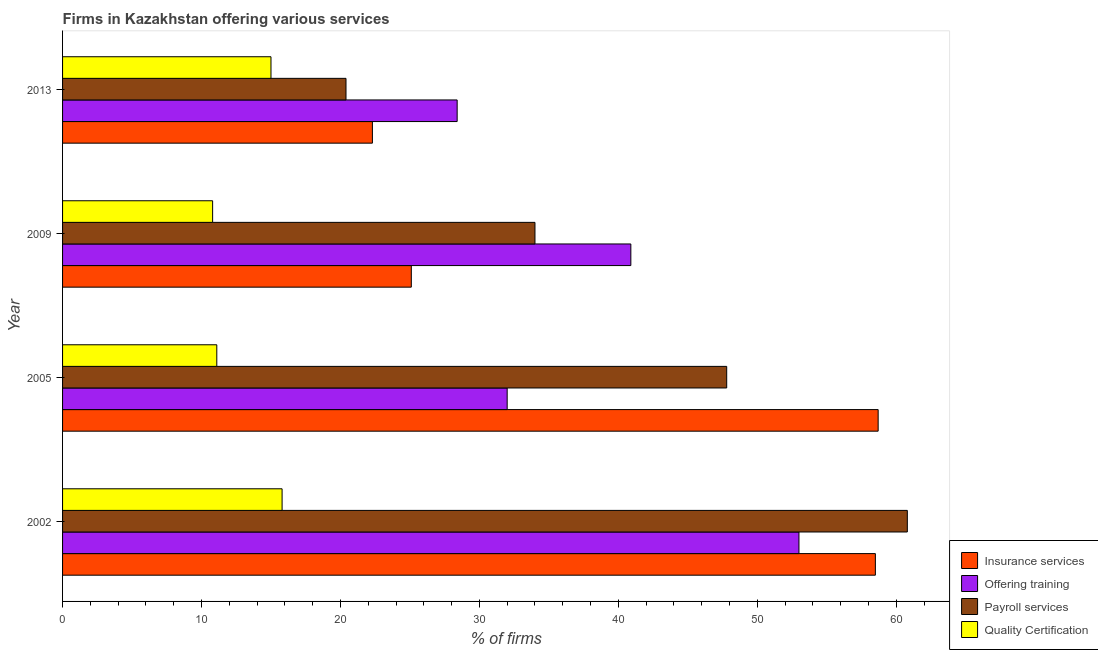How many different coloured bars are there?
Ensure brevity in your answer.  4. Are the number of bars on each tick of the Y-axis equal?
Your response must be concise. Yes. In how many cases, is the number of bars for a given year not equal to the number of legend labels?
Your answer should be compact. 0. What is the percentage of firms offering payroll services in 2002?
Make the answer very short. 60.8. Across all years, what is the maximum percentage of firms offering insurance services?
Ensure brevity in your answer.  58.7. Across all years, what is the minimum percentage of firms offering payroll services?
Your answer should be compact. 20.4. In which year was the percentage of firms offering payroll services maximum?
Offer a very short reply. 2002. What is the total percentage of firms offering quality certification in the graph?
Your answer should be compact. 52.7. What is the difference between the percentage of firms offering training in 2002 and that in 2013?
Offer a terse response. 24.6. What is the average percentage of firms offering quality certification per year?
Provide a succinct answer. 13.18. In the year 2009, what is the difference between the percentage of firms offering quality certification and percentage of firms offering insurance services?
Offer a very short reply. -14.3. In how many years, is the percentage of firms offering training greater than 6 %?
Ensure brevity in your answer.  4. What is the ratio of the percentage of firms offering payroll services in 2005 to that in 2009?
Offer a very short reply. 1.41. Is the difference between the percentage of firms offering insurance services in 2005 and 2009 greater than the difference between the percentage of firms offering payroll services in 2005 and 2009?
Provide a short and direct response. Yes. What is the difference between the highest and the second highest percentage of firms offering insurance services?
Keep it short and to the point. 0.2. What is the difference between the highest and the lowest percentage of firms offering training?
Your answer should be very brief. 24.6. In how many years, is the percentage of firms offering insurance services greater than the average percentage of firms offering insurance services taken over all years?
Your answer should be compact. 2. Is the sum of the percentage of firms offering payroll services in 2002 and 2005 greater than the maximum percentage of firms offering training across all years?
Provide a short and direct response. Yes. Is it the case that in every year, the sum of the percentage of firms offering training and percentage of firms offering payroll services is greater than the sum of percentage of firms offering insurance services and percentage of firms offering quality certification?
Your response must be concise. No. What does the 2nd bar from the top in 2013 represents?
Your answer should be very brief. Payroll services. What does the 1st bar from the bottom in 2005 represents?
Make the answer very short. Insurance services. How many years are there in the graph?
Offer a terse response. 4. Are the values on the major ticks of X-axis written in scientific E-notation?
Offer a very short reply. No. Where does the legend appear in the graph?
Make the answer very short. Bottom right. What is the title of the graph?
Give a very brief answer. Firms in Kazakhstan offering various services . What is the label or title of the X-axis?
Your answer should be very brief. % of firms. What is the label or title of the Y-axis?
Provide a succinct answer. Year. What is the % of firms in Insurance services in 2002?
Provide a succinct answer. 58.5. What is the % of firms in Offering training in 2002?
Offer a terse response. 53. What is the % of firms in Payroll services in 2002?
Provide a short and direct response. 60.8. What is the % of firms in Insurance services in 2005?
Make the answer very short. 58.7. What is the % of firms in Payroll services in 2005?
Make the answer very short. 47.8. What is the % of firms in Quality Certification in 2005?
Give a very brief answer. 11.1. What is the % of firms in Insurance services in 2009?
Your answer should be compact. 25.1. What is the % of firms of Offering training in 2009?
Ensure brevity in your answer.  40.9. What is the % of firms in Insurance services in 2013?
Provide a succinct answer. 22.3. What is the % of firms in Offering training in 2013?
Your answer should be compact. 28.4. What is the % of firms of Payroll services in 2013?
Your answer should be compact. 20.4. What is the % of firms in Quality Certification in 2013?
Give a very brief answer. 15. Across all years, what is the maximum % of firms of Insurance services?
Your answer should be compact. 58.7. Across all years, what is the maximum % of firms of Payroll services?
Provide a succinct answer. 60.8. Across all years, what is the maximum % of firms in Quality Certification?
Offer a terse response. 15.8. Across all years, what is the minimum % of firms of Insurance services?
Keep it short and to the point. 22.3. Across all years, what is the minimum % of firms in Offering training?
Offer a very short reply. 28.4. Across all years, what is the minimum % of firms of Payroll services?
Make the answer very short. 20.4. What is the total % of firms in Insurance services in the graph?
Your answer should be very brief. 164.6. What is the total % of firms of Offering training in the graph?
Your answer should be compact. 154.3. What is the total % of firms in Payroll services in the graph?
Offer a very short reply. 163. What is the total % of firms of Quality Certification in the graph?
Offer a terse response. 52.7. What is the difference between the % of firms of Offering training in 2002 and that in 2005?
Your answer should be very brief. 21. What is the difference between the % of firms in Payroll services in 2002 and that in 2005?
Provide a short and direct response. 13. What is the difference between the % of firms of Quality Certification in 2002 and that in 2005?
Offer a terse response. 4.7. What is the difference between the % of firms in Insurance services in 2002 and that in 2009?
Offer a terse response. 33.4. What is the difference between the % of firms in Payroll services in 2002 and that in 2009?
Provide a short and direct response. 26.8. What is the difference between the % of firms in Insurance services in 2002 and that in 2013?
Give a very brief answer. 36.2. What is the difference between the % of firms of Offering training in 2002 and that in 2013?
Ensure brevity in your answer.  24.6. What is the difference between the % of firms in Payroll services in 2002 and that in 2013?
Your answer should be compact. 40.4. What is the difference between the % of firms in Quality Certification in 2002 and that in 2013?
Provide a short and direct response. 0.8. What is the difference between the % of firms of Insurance services in 2005 and that in 2009?
Your answer should be very brief. 33.6. What is the difference between the % of firms of Payroll services in 2005 and that in 2009?
Your answer should be compact. 13.8. What is the difference between the % of firms in Quality Certification in 2005 and that in 2009?
Offer a terse response. 0.3. What is the difference between the % of firms of Insurance services in 2005 and that in 2013?
Your answer should be compact. 36.4. What is the difference between the % of firms of Payroll services in 2005 and that in 2013?
Offer a terse response. 27.4. What is the difference between the % of firms of Quality Certification in 2005 and that in 2013?
Give a very brief answer. -3.9. What is the difference between the % of firms in Offering training in 2009 and that in 2013?
Provide a short and direct response. 12.5. What is the difference between the % of firms in Payroll services in 2009 and that in 2013?
Your answer should be compact. 13.6. What is the difference between the % of firms of Insurance services in 2002 and the % of firms of Offering training in 2005?
Ensure brevity in your answer.  26.5. What is the difference between the % of firms of Insurance services in 2002 and the % of firms of Quality Certification in 2005?
Ensure brevity in your answer.  47.4. What is the difference between the % of firms of Offering training in 2002 and the % of firms of Payroll services in 2005?
Give a very brief answer. 5.2. What is the difference between the % of firms of Offering training in 2002 and the % of firms of Quality Certification in 2005?
Ensure brevity in your answer.  41.9. What is the difference between the % of firms in Payroll services in 2002 and the % of firms in Quality Certification in 2005?
Keep it short and to the point. 49.7. What is the difference between the % of firms in Insurance services in 2002 and the % of firms in Offering training in 2009?
Provide a succinct answer. 17.6. What is the difference between the % of firms in Insurance services in 2002 and the % of firms in Payroll services in 2009?
Give a very brief answer. 24.5. What is the difference between the % of firms of Insurance services in 2002 and the % of firms of Quality Certification in 2009?
Offer a very short reply. 47.7. What is the difference between the % of firms in Offering training in 2002 and the % of firms in Payroll services in 2009?
Provide a short and direct response. 19. What is the difference between the % of firms of Offering training in 2002 and the % of firms of Quality Certification in 2009?
Provide a succinct answer. 42.2. What is the difference between the % of firms of Payroll services in 2002 and the % of firms of Quality Certification in 2009?
Ensure brevity in your answer.  50. What is the difference between the % of firms of Insurance services in 2002 and the % of firms of Offering training in 2013?
Your answer should be very brief. 30.1. What is the difference between the % of firms in Insurance services in 2002 and the % of firms in Payroll services in 2013?
Give a very brief answer. 38.1. What is the difference between the % of firms in Insurance services in 2002 and the % of firms in Quality Certification in 2013?
Ensure brevity in your answer.  43.5. What is the difference between the % of firms of Offering training in 2002 and the % of firms of Payroll services in 2013?
Your answer should be very brief. 32.6. What is the difference between the % of firms of Payroll services in 2002 and the % of firms of Quality Certification in 2013?
Give a very brief answer. 45.8. What is the difference between the % of firms in Insurance services in 2005 and the % of firms in Payroll services in 2009?
Make the answer very short. 24.7. What is the difference between the % of firms in Insurance services in 2005 and the % of firms in Quality Certification in 2009?
Your response must be concise. 47.9. What is the difference between the % of firms of Offering training in 2005 and the % of firms of Quality Certification in 2009?
Give a very brief answer. 21.2. What is the difference between the % of firms in Payroll services in 2005 and the % of firms in Quality Certification in 2009?
Make the answer very short. 37. What is the difference between the % of firms in Insurance services in 2005 and the % of firms in Offering training in 2013?
Provide a succinct answer. 30.3. What is the difference between the % of firms of Insurance services in 2005 and the % of firms of Payroll services in 2013?
Make the answer very short. 38.3. What is the difference between the % of firms of Insurance services in 2005 and the % of firms of Quality Certification in 2013?
Provide a short and direct response. 43.7. What is the difference between the % of firms in Payroll services in 2005 and the % of firms in Quality Certification in 2013?
Offer a terse response. 32.8. What is the difference between the % of firms of Insurance services in 2009 and the % of firms of Offering training in 2013?
Offer a terse response. -3.3. What is the difference between the % of firms in Insurance services in 2009 and the % of firms in Quality Certification in 2013?
Keep it short and to the point. 10.1. What is the difference between the % of firms in Offering training in 2009 and the % of firms in Quality Certification in 2013?
Give a very brief answer. 25.9. What is the average % of firms of Insurance services per year?
Your response must be concise. 41.15. What is the average % of firms in Offering training per year?
Your answer should be compact. 38.58. What is the average % of firms of Payroll services per year?
Provide a short and direct response. 40.75. What is the average % of firms of Quality Certification per year?
Give a very brief answer. 13.18. In the year 2002, what is the difference between the % of firms in Insurance services and % of firms in Payroll services?
Offer a terse response. -2.3. In the year 2002, what is the difference between the % of firms of Insurance services and % of firms of Quality Certification?
Ensure brevity in your answer.  42.7. In the year 2002, what is the difference between the % of firms of Offering training and % of firms of Quality Certification?
Give a very brief answer. 37.2. In the year 2005, what is the difference between the % of firms of Insurance services and % of firms of Offering training?
Offer a very short reply. 26.7. In the year 2005, what is the difference between the % of firms in Insurance services and % of firms in Payroll services?
Make the answer very short. 10.9. In the year 2005, what is the difference between the % of firms in Insurance services and % of firms in Quality Certification?
Your response must be concise. 47.6. In the year 2005, what is the difference between the % of firms in Offering training and % of firms in Payroll services?
Your answer should be very brief. -15.8. In the year 2005, what is the difference between the % of firms of Offering training and % of firms of Quality Certification?
Give a very brief answer. 20.9. In the year 2005, what is the difference between the % of firms in Payroll services and % of firms in Quality Certification?
Your response must be concise. 36.7. In the year 2009, what is the difference between the % of firms of Insurance services and % of firms of Offering training?
Ensure brevity in your answer.  -15.8. In the year 2009, what is the difference between the % of firms in Insurance services and % of firms in Quality Certification?
Your response must be concise. 14.3. In the year 2009, what is the difference between the % of firms of Offering training and % of firms of Payroll services?
Offer a very short reply. 6.9. In the year 2009, what is the difference between the % of firms in Offering training and % of firms in Quality Certification?
Your answer should be compact. 30.1. In the year 2009, what is the difference between the % of firms of Payroll services and % of firms of Quality Certification?
Give a very brief answer. 23.2. In the year 2013, what is the difference between the % of firms in Insurance services and % of firms in Payroll services?
Your answer should be compact. 1.9. In the year 2013, what is the difference between the % of firms of Offering training and % of firms of Payroll services?
Offer a terse response. 8. In the year 2013, what is the difference between the % of firms of Offering training and % of firms of Quality Certification?
Ensure brevity in your answer.  13.4. In the year 2013, what is the difference between the % of firms in Payroll services and % of firms in Quality Certification?
Give a very brief answer. 5.4. What is the ratio of the % of firms of Insurance services in 2002 to that in 2005?
Your answer should be compact. 1. What is the ratio of the % of firms in Offering training in 2002 to that in 2005?
Offer a terse response. 1.66. What is the ratio of the % of firms of Payroll services in 2002 to that in 2005?
Offer a terse response. 1.27. What is the ratio of the % of firms of Quality Certification in 2002 to that in 2005?
Make the answer very short. 1.42. What is the ratio of the % of firms of Insurance services in 2002 to that in 2009?
Offer a very short reply. 2.33. What is the ratio of the % of firms of Offering training in 2002 to that in 2009?
Give a very brief answer. 1.3. What is the ratio of the % of firms of Payroll services in 2002 to that in 2009?
Give a very brief answer. 1.79. What is the ratio of the % of firms of Quality Certification in 2002 to that in 2009?
Ensure brevity in your answer.  1.46. What is the ratio of the % of firms of Insurance services in 2002 to that in 2013?
Give a very brief answer. 2.62. What is the ratio of the % of firms in Offering training in 2002 to that in 2013?
Keep it short and to the point. 1.87. What is the ratio of the % of firms of Payroll services in 2002 to that in 2013?
Make the answer very short. 2.98. What is the ratio of the % of firms in Quality Certification in 2002 to that in 2013?
Your response must be concise. 1.05. What is the ratio of the % of firms of Insurance services in 2005 to that in 2009?
Provide a short and direct response. 2.34. What is the ratio of the % of firms of Offering training in 2005 to that in 2009?
Your response must be concise. 0.78. What is the ratio of the % of firms in Payroll services in 2005 to that in 2009?
Offer a terse response. 1.41. What is the ratio of the % of firms of Quality Certification in 2005 to that in 2009?
Give a very brief answer. 1.03. What is the ratio of the % of firms of Insurance services in 2005 to that in 2013?
Provide a short and direct response. 2.63. What is the ratio of the % of firms of Offering training in 2005 to that in 2013?
Offer a terse response. 1.13. What is the ratio of the % of firms of Payroll services in 2005 to that in 2013?
Your response must be concise. 2.34. What is the ratio of the % of firms of Quality Certification in 2005 to that in 2013?
Your answer should be very brief. 0.74. What is the ratio of the % of firms in Insurance services in 2009 to that in 2013?
Give a very brief answer. 1.13. What is the ratio of the % of firms in Offering training in 2009 to that in 2013?
Make the answer very short. 1.44. What is the ratio of the % of firms in Payroll services in 2009 to that in 2013?
Keep it short and to the point. 1.67. What is the ratio of the % of firms in Quality Certification in 2009 to that in 2013?
Provide a short and direct response. 0.72. What is the difference between the highest and the second highest % of firms of Insurance services?
Offer a terse response. 0.2. What is the difference between the highest and the lowest % of firms of Insurance services?
Provide a succinct answer. 36.4. What is the difference between the highest and the lowest % of firms of Offering training?
Provide a succinct answer. 24.6. What is the difference between the highest and the lowest % of firms in Payroll services?
Offer a very short reply. 40.4. What is the difference between the highest and the lowest % of firms in Quality Certification?
Offer a very short reply. 5. 